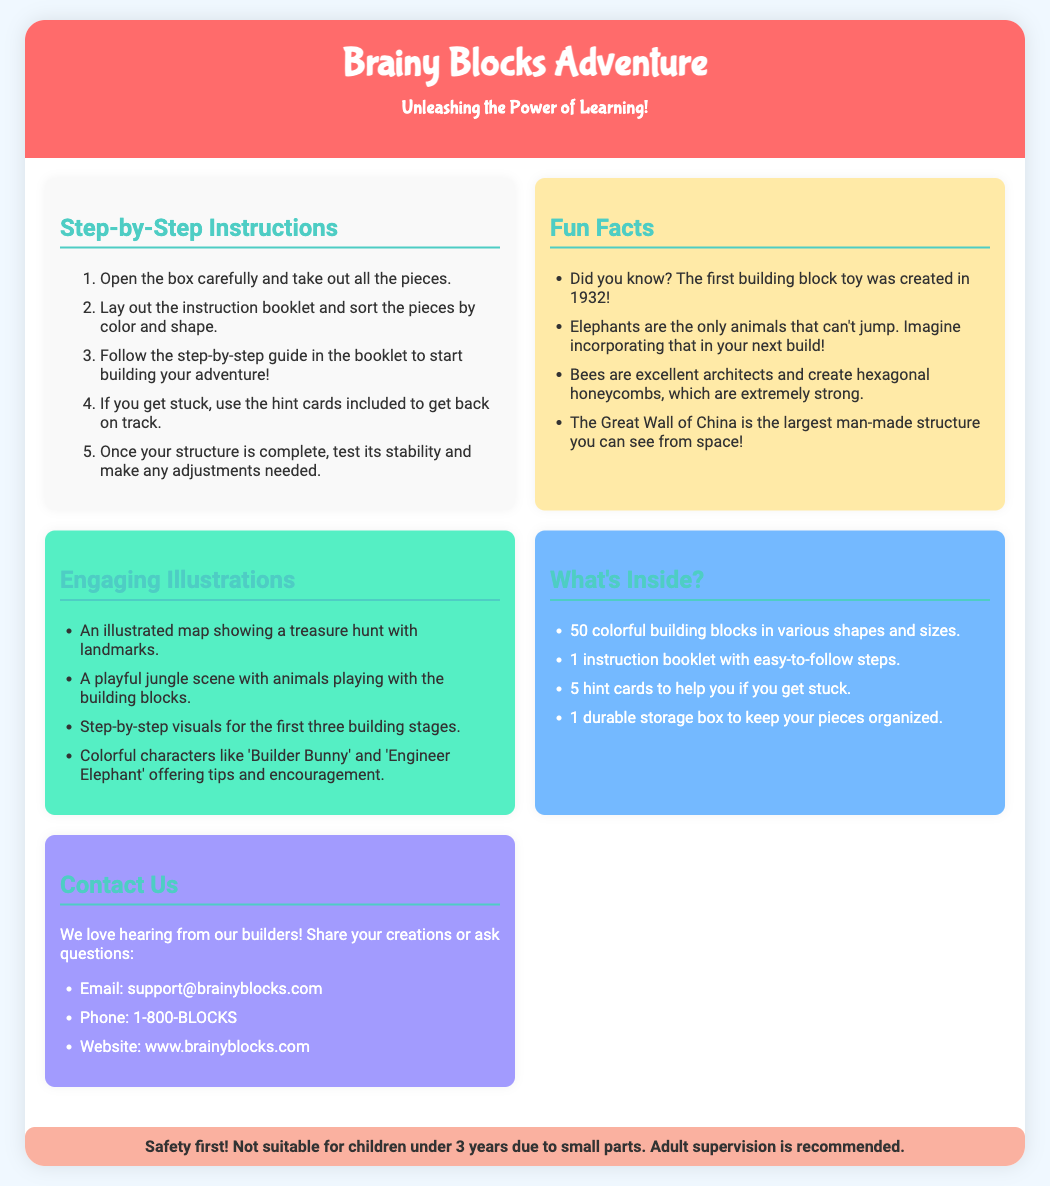what is the product name? The product name is displayed prominently at the top of the document.
Answer: Brainy Blocks Adventure how many building blocks are included? The number of building blocks is specified in the "What's Inside?" section.
Answer: 50 colorful building blocks what colors are mentioned in the instructions? The colors referred to in the instructions relate to sorting the pieces, which are featured in the steps.
Answer: Various colors who are the characters illustrated in the engaging illustrations? The characters are named in the "Engaging Illustrations" section.
Answer: Builder Bunny and Engineer Elephant what year was the first building block toy created? The year is mentioned in the "Fun Facts" section of the document.
Answer: 1932 how many hint cards are included? The number of hint cards is stated in the "What's Inside?" section.
Answer: 5 hint cards what is the contact email for support? The contact email is given under the "Contact Us" section.
Answer: support@brainyblocks.com what is the background color of the fun facts section? The background color is described in the styling section for the fun facts.
Answer: #ffeaa7 what should be done if you get stuck? This action is specified in the steps of the instructions.
Answer: Use the hint cards 